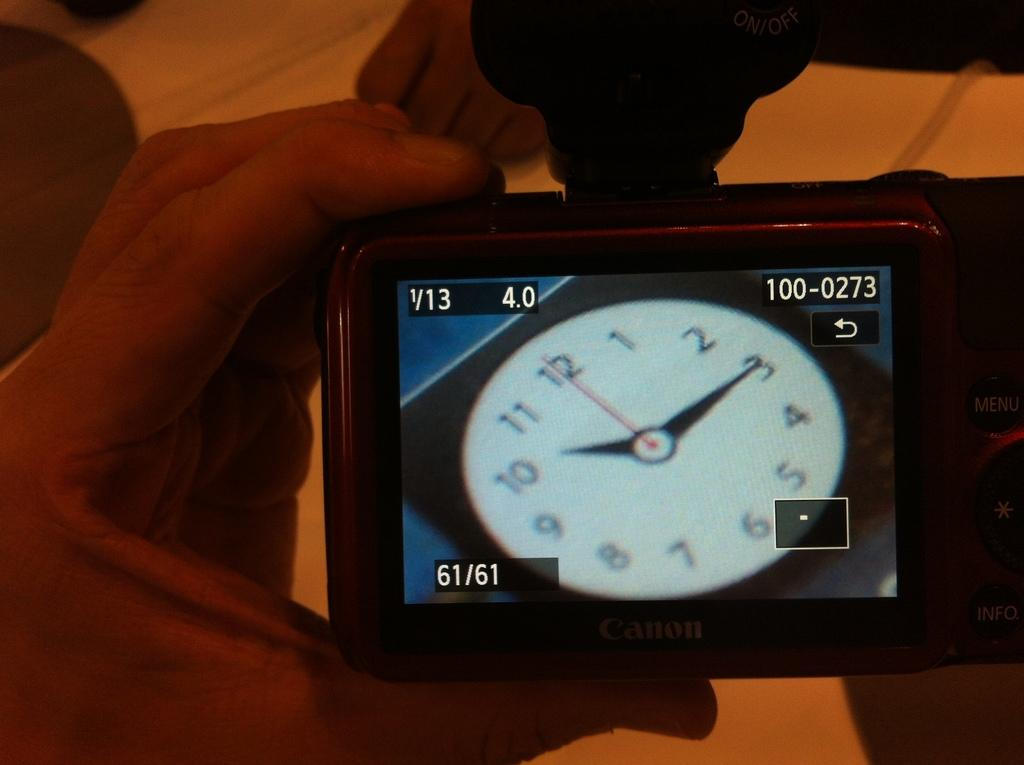<image>
Present a compact description of the photo's key features. A Canon camera with a clock showing on the display. 